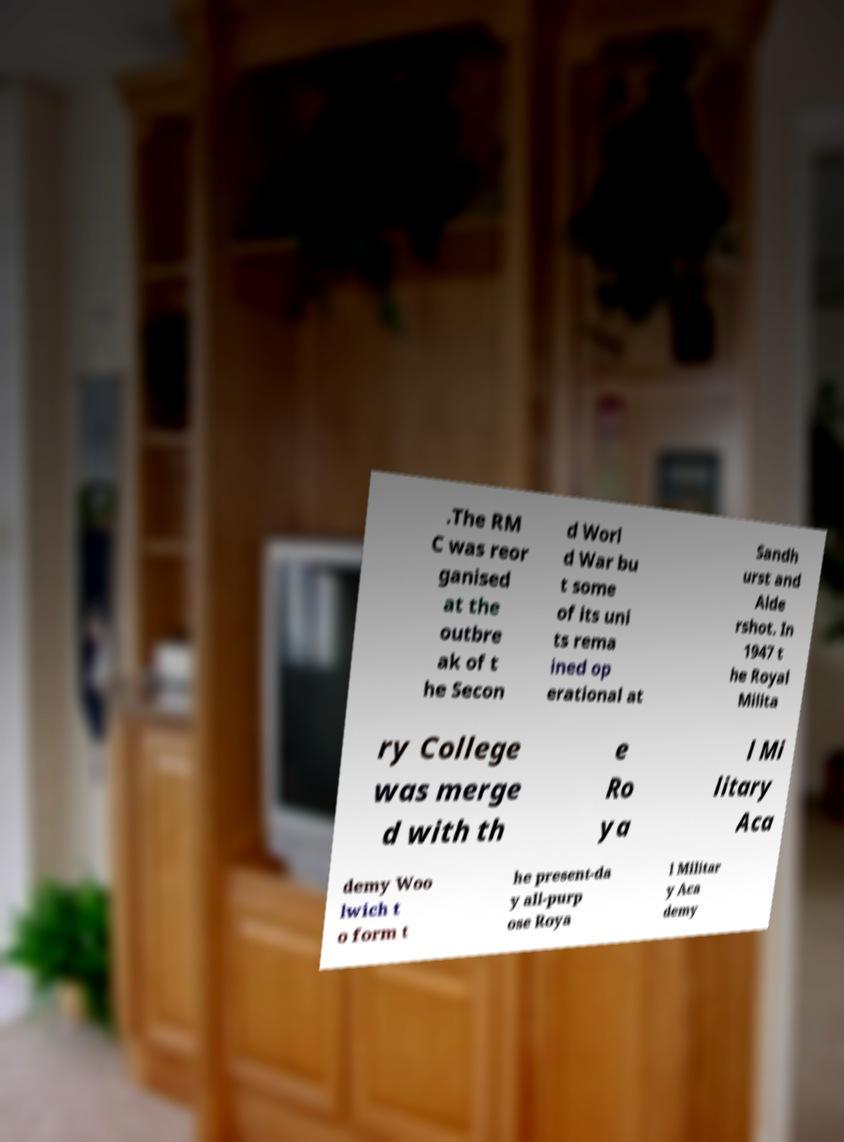Can you read and provide the text displayed in the image?This photo seems to have some interesting text. Can you extract and type it out for me? .The RM C was reor ganised at the outbre ak of t he Secon d Worl d War bu t some of its uni ts rema ined op erational at Sandh urst and Alde rshot. In 1947 t he Royal Milita ry College was merge d with th e Ro ya l Mi litary Aca demy Woo lwich t o form t he present-da y all-purp ose Roya l Militar y Aca demy 